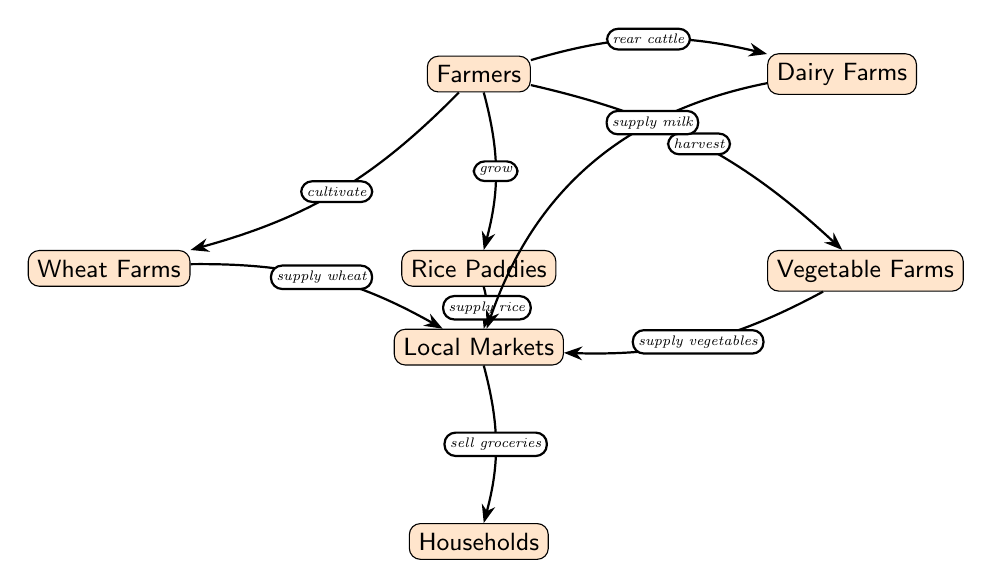What are the sources of food in households? The diagram lists Local Markets as the main source of food for Households.
Answer: Local Markets Who cultivates wheat? The diagram shows that Farmers cultivate wheat on Wheat Farms.
Answer: Farmers How many types of farms are represented in the diagram? There are four types of farms represented: Wheat Farms, Rice Paddies, Vegetable Farms, and Dairy Farms.
Answer: Four What is supplied by Vegetable Farms? The diagram indicates that Vegetable Farms supply vegetables to Local Markets.
Answer: Vegetables What is the relationship between Dairy Farms and Local Markets? The diagram illustrates that Dairy Farms supply milk to Local Markets, which indicates a direct connection for the delivery of dairy products.
Answer: Supply milk Which node connects Farmers and Households? The edge that connects Farmers to Households is Local Markets, which indicates that the food produced by farmers is sold there before reaching households.
Answer: Local Markets How do Rice Paddies contribute to Local Markets? Rice Paddies grow rice, which is then supplied to Local Markets, showing their direct role in contributing to food availability in the market.
Answer: Supply rice If you want to buy groceries, which node would you go to? The diagram shows that Households go to Local Markets to buy groceries, indicating that Local Markets are the point of purchase for food items.
Answer: Local Markets What action connects Farmers to Dairy Farms? The diagram reveals that Farmers rear cattle, which connects them to Dairy Farms, indicating the source of dairy products from these farms.
Answer: Rear cattle 